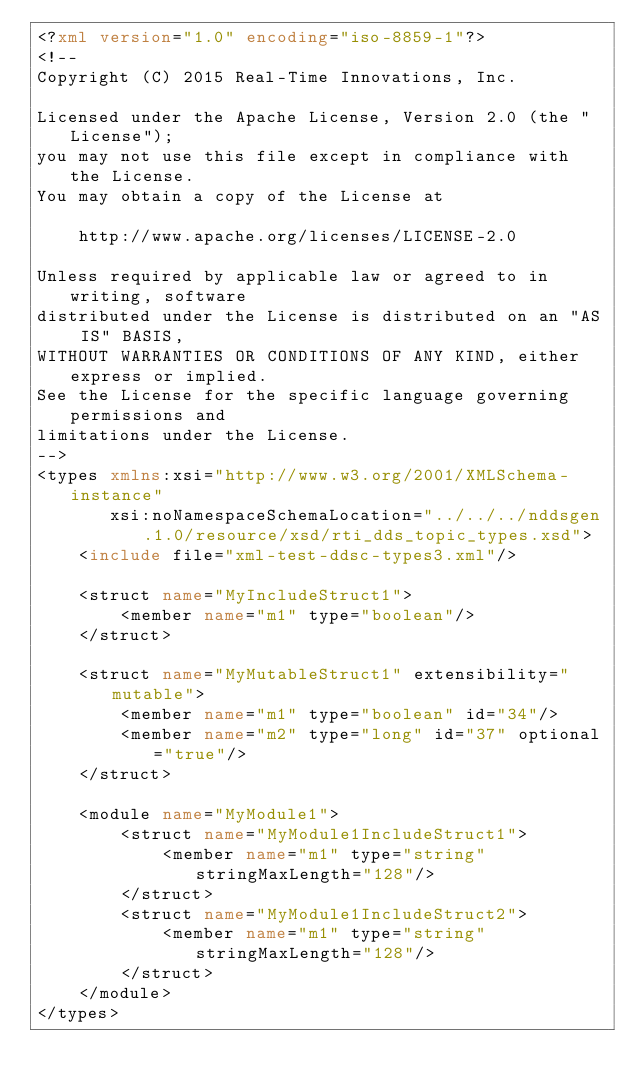Convert code to text. <code><loc_0><loc_0><loc_500><loc_500><_XML_><?xml version="1.0" encoding="iso-8859-1"?>
<!-- 
Copyright (C) 2015 Real-Time Innovations, Inc.

Licensed under the Apache License, Version 2.0 (the "License");
you may not use this file except in compliance with the License.
You may obtain a copy of the License at

    http://www.apache.org/licenses/LICENSE-2.0

Unless required by applicable law or agreed to in writing, software
distributed under the License is distributed on an "AS IS" BASIS,
WITHOUT WARRANTIES OR CONDITIONS OF ANY KIND, either express or implied.
See the License for the specific language governing permissions and
limitations under the License.
-->
<types xmlns:xsi="http://www.w3.org/2001/XMLSchema-instance" 
       xsi:noNamespaceSchemaLocation="../../../nddsgen.1.0/resource/xsd/rti_dds_topic_types.xsd">
    <include file="xml-test-ddsc-types3.xml"/>
    
    <struct name="MyIncludeStruct1">
        <member name="m1" type="boolean"/>
    </struct>
    
    <struct name="MyMutableStruct1" extensibility="mutable">
        <member name="m1" type="boolean" id="34"/>
        <member name="m2" type="long" id="37" optional="true"/>        
    </struct>

    <module name="MyModule1">
        <struct name="MyModule1IncludeStruct1">
            <member name="m1" type="string" stringMaxLength="128"/>
        </struct>
        <struct name="MyModule1IncludeStruct2">
            <member name="m1" type="string" stringMaxLength="128"/>
        </struct>
    </module>
</types>
</code> 